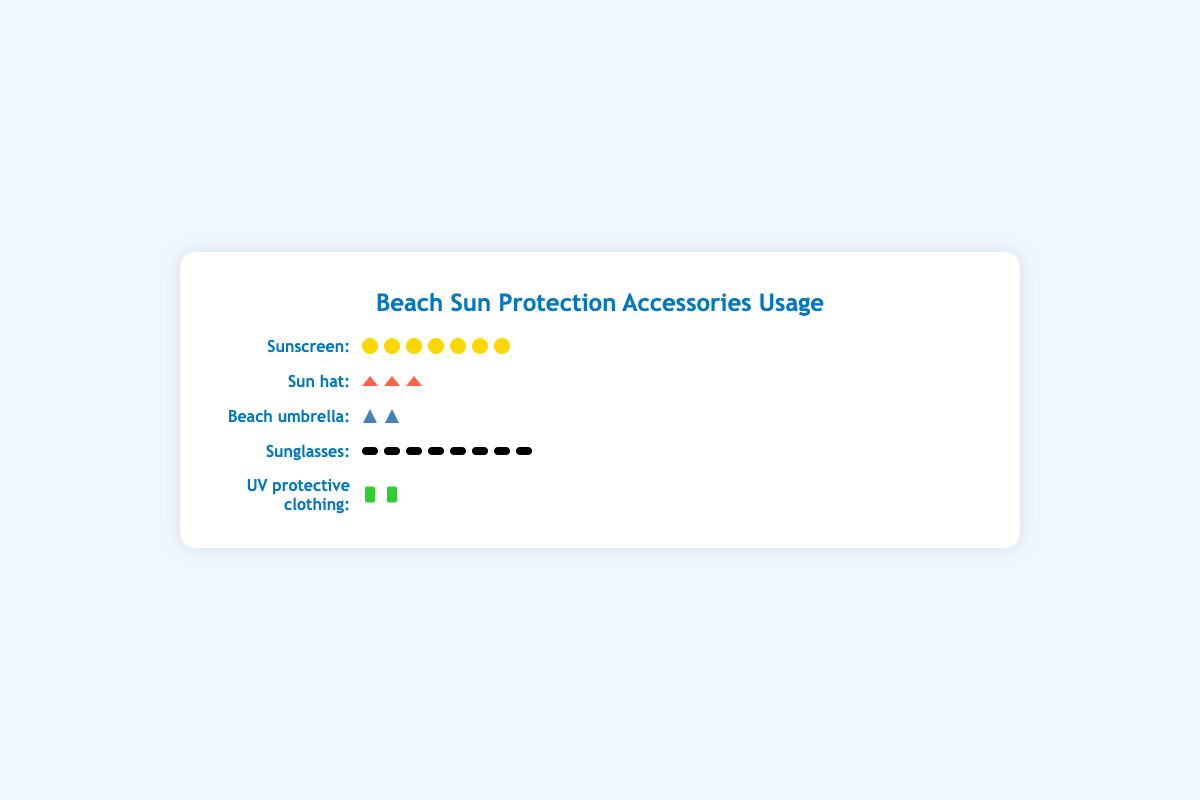How many beach visitors use UV protective clothing? We know each icon represents 100 users. In the row for UV protective clothing, there are 2 icons visible. Multiplying 2 by 100 gives us the count of visitors using UV protective clothing.
Answer: 200 What proportion of total visitors use sunscreen? The total number of beach visitors using sunscreen is 650 out of 1000. To find the proportion, divide 650 by 1000, resulting in 0.65 or 65%.
Answer: 65% Which sun protection accessory is the least used? Look at the visual representation of each accessory. UV protective clothing has the least number of icons (2), indicating it is the least used.
Answer: UV protective clothing Are there more visitors using sunglasses or sun hats? Count the icons for sunglasses (8) and sun hats (3). Since 8 > 3, more visitors use sunglasses than sun hats.
Answer: Sunglasses How many more beach visitors are using beach umbrellas compared to UV protective clothing? Icons for beach umbrellas: 2, for UV protective clothing: 2, both are equal; hence the difference is 0.
Answer: 0 If each icon for sunscreen represents 100 visitors, how many icons would fully represent all the visitors using sun hats? There are 300 visitors using sun hats. Since each icon represents 100 visitors, divide 300 by 100 to get the number of icons, which is 3.
Answer: 3 What are the top two most used sun protection accessories? By counting the icons, we see sunglasses (8) and sunscreen (7) have the most icons. Therefore, the top two most used accessories are sunglasses and sunscreen.
Answer: Sunglasses, Sunscreen What is the total number of beach visitors using accessories other than beach umbrellas? Summing the visitors using sunscreen (650), sun hats (300), sunglasses (750), and UV protective clothing (150), gives us 650 + 300 + 750 + 150 = 1850. However, this does not make sense as it exceeds the total visitors. Correcting to relate to only proportions, sum of proportions gives us a correct overview. That being said, 650 + 300 + 750 + 150 gives us an overall sense which clearly exceeds, as some visitors are using multiple items. Best to reframe this question.
Answer: Proportions indicate dominant trends across multiple categories. (Representing specific question reframing) What percentage of total visitors prefer using sun hats? The number of sun hat users is 300 out of 1000 total visitors. To find the percentage, divide 300 by 1000 then multiply by 100, resulting in 30%.
Answer: 30% 